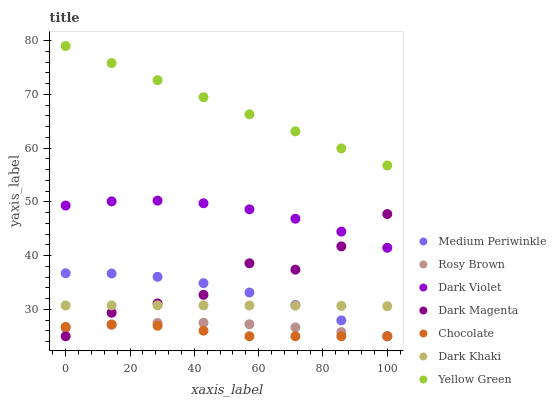Does Chocolate have the minimum area under the curve?
Answer yes or no. Yes. Does Yellow Green have the maximum area under the curve?
Answer yes or no. Yes. Does Rosy Brown have the minimum area under the curve?
Answer yes or no. No. Does Rosy Brown have the maximum area under the curve?
Answer yes or no. No. Is Yellow Green the smoothest?
Answer yes or no. Yes. Is Dark Magenta the roughest?
Answer yes or no. Yes. Is Rosy Brown the smoothest?
Answer yes or no. No. Is Rosy Brown the roughest?
Answer yes or no. No. Does Dark Magenta have the lowest value?
Answer yes or no. Yes. Does Dark Violet have the lowest value?
Answer yes or no. No. Does Yellow Green have the highest value?
Answer yes or no. Yes. Does Rosy Brown have the highest value?
Answer yes or no. No. Is Chocolate less than Yellow Green?
Answer yes or no. Yes. Is Dark Violet greater than Rosy Brown?
Answer yes or no. Yes. Does Chocolate intersect Medium Periwinkle?
Answer yes or no. Yes. Is Chocolate less than Medium Periwinkle?
Answer yes or no. No. Is Chocolate greater than Medium Periwinkle?
Answer yes or no. No. Does Chocolate intersect Yellow Green?
Answer yes or no. No. 